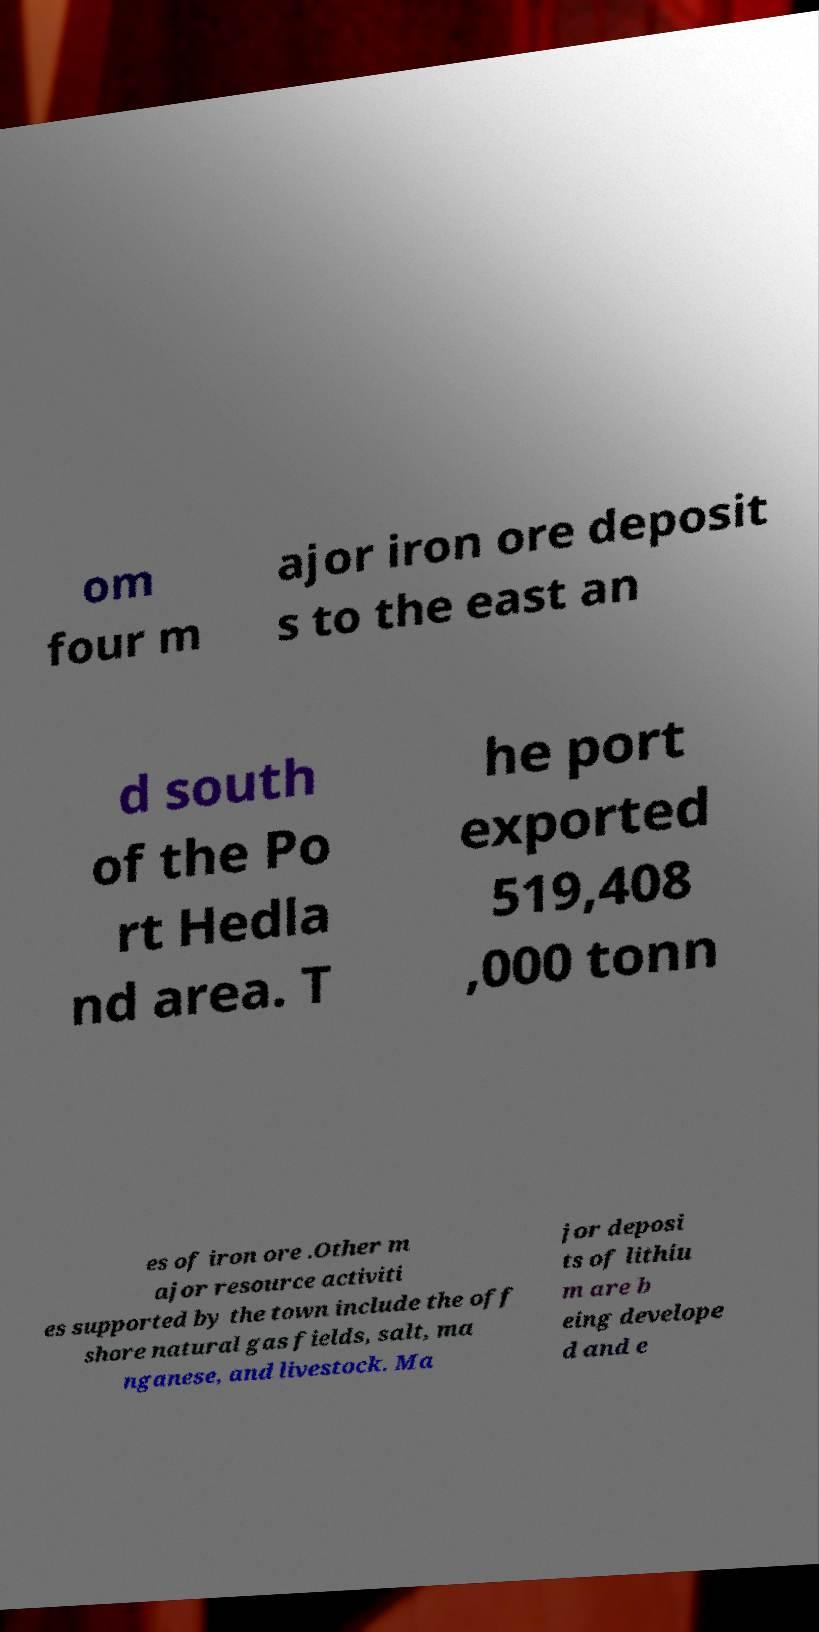Could you extract and type out the text from this image? om four m ajor iron ore deposit s to the east an d south of the Po rt Hedla nd area. T he port exported 519,408 ,000 tonn es of iron ore .Other m ajor resource activiti es supported by the town include the off shore natural gas fields, salt, ma nganese, and livestock. Ma jor deposi ts of lithiu m are b eing develope d and e 